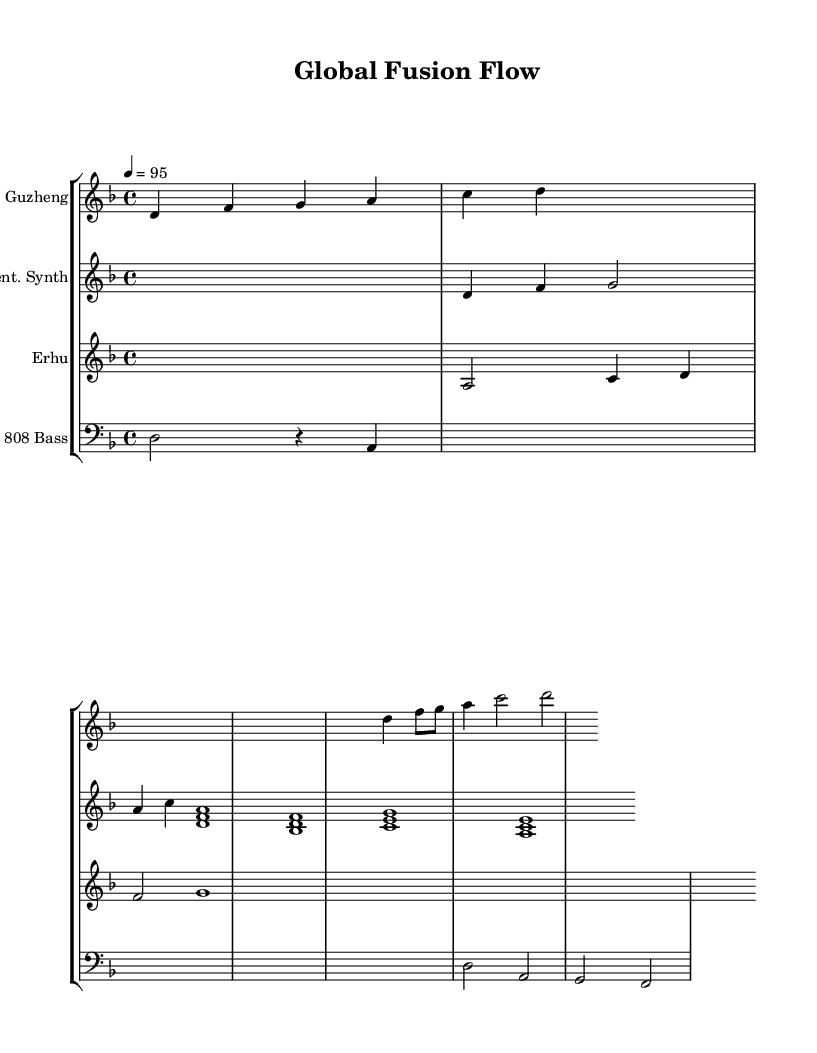What is the key signature of this music? The key signature indicated in the music is D minor, which typically consists of one flat (B♭). It can be identified within the global settings at the beginning of the score.
Answer: D minor What is the time signature of this music? The time signature listed in the music is 4/4, meaning there are four beats per measure, and a quarter note receives one beat. This is specified in the global settings of the sheet music.
Answer: 4/4 What is the tempo marking for this piece? The tempo marking shows that the piece is set to a speed of 95 beats per minute (BPM), which can be found in the global settings section.
Answer: 95 Which instrument plays the chorus section? The instruments that play the chorus section are the Guzheng and the Pent. Synth, as indicated by the respective measures where their parts begin.
Answer: Guzheng and Pent. Synth How many measures does the Guzheng have in the introduction? The Guzheng introduction contains 5 measures as indicated by the notes included in that section, including the placeholder for the verse that follows.
Answer: 5 What does the transition from the verse to the chorus demonstrate in hip-hop? The transition portrays the contrast and dynamics often found in hip-hop, emphasizing the beat switch and featuring different instrumental textures, in this case, integrating Asian musical elements.
Answer: Contrast and dynamics How is the Erhu utilized in this piece? The Erhu plays melodic lines primarily in the verse to provide an Asian element and blends with the modern production, characteristic of East meets West fusion hip-hop, as indicated in the structure of the score.
Answer: Melodic lines in verse 